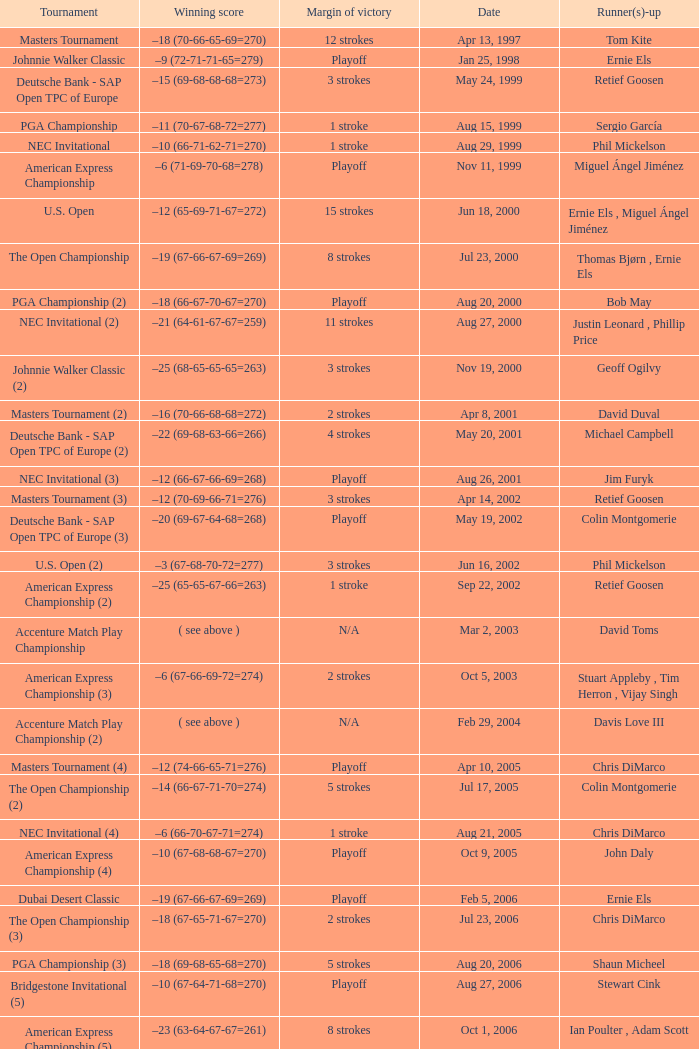Who is Runner(s)-up that has a Date of may 24, 1999? Retief Goosen. 